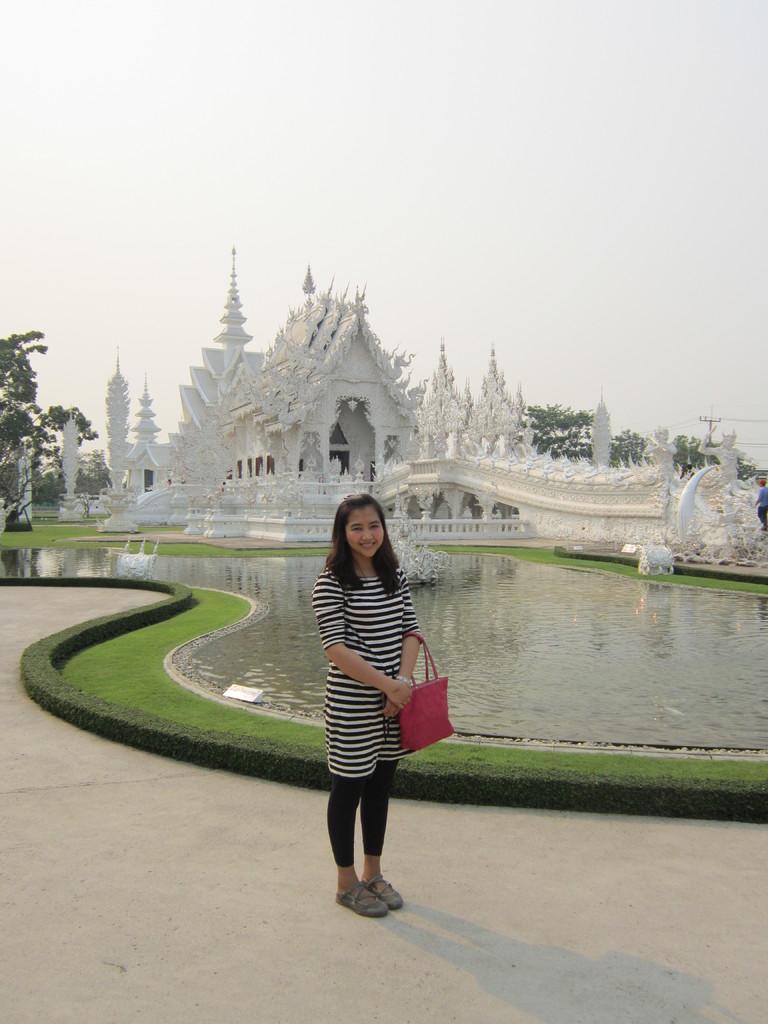Can you describe this image briefly? In the middle of the image a woman is standing and holding a bag and smiling. Behind her there are some water and there is grass. Behind her there is a building and there are some trees. At the top of the image there is sky. 